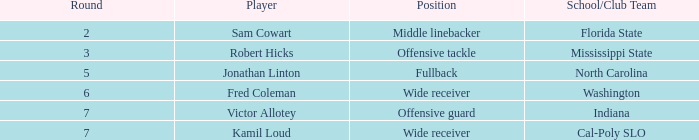In which round is a team from an indiana school/club present, having a pick number below 198? None. 